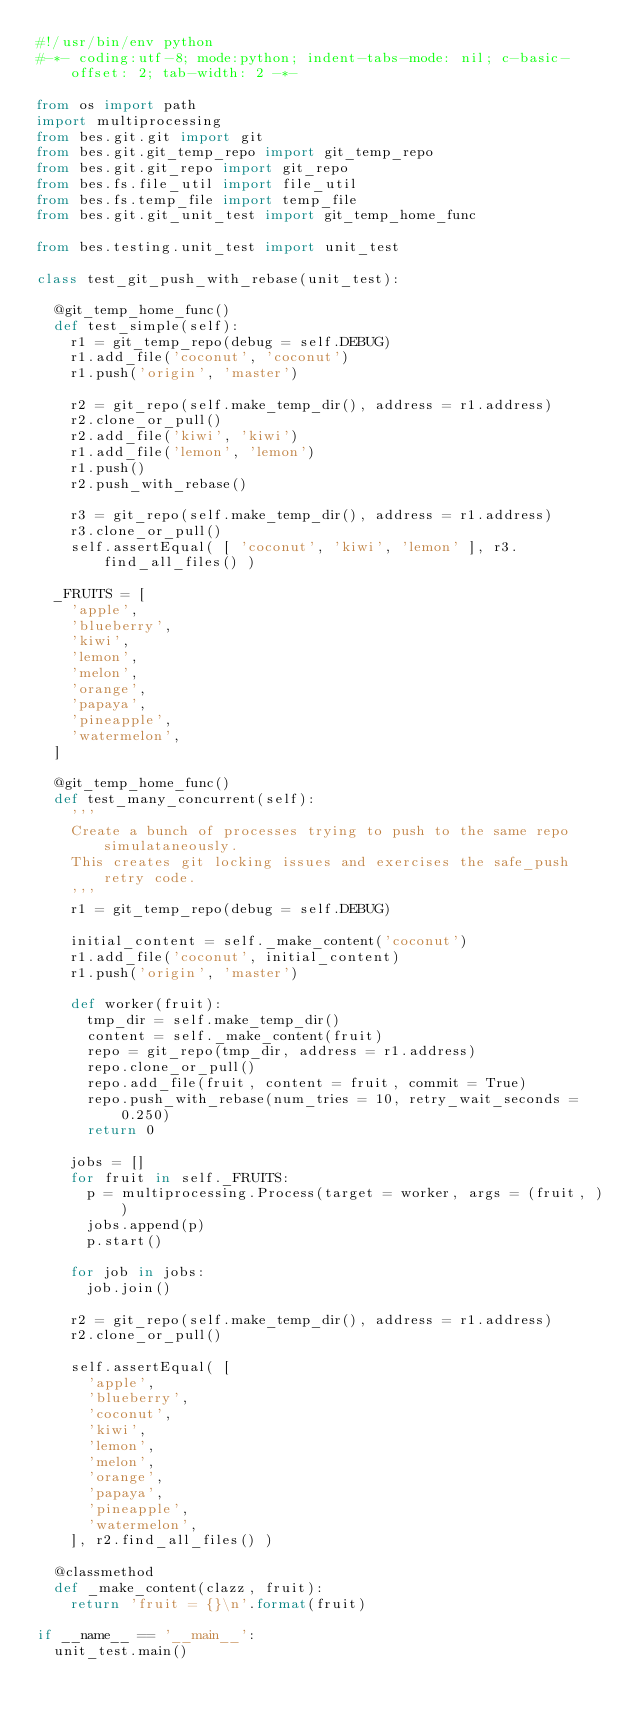Convert code to text. <code><loc_0><loc_0><loc_500><loc_500><_Python_>#!/usr/bin/env python
#-*- coding:utf-8; mode:python; indent-tabs-mode: nil; c-basic-offset: 2; tab-width: 2 -*-

from os import path
import multiprocessing
from bes.git.git import git
from bes.git.git_temp_repo import git_temp_repo
from bes.git.git_repo import git_repo
from bes.fs.file_util import file_util
from bes.fs.temp_file import temp_file
from bes.git.git_unit_test import git_temp_home_func

from bes.testing.unit_test import unit_test

class test_git_push_with_rebase(unit_test):

  @git_temp_home_func()
  def test_simple(self):
    r1 = git_temp_repo(debug = self.DEBUG)
    r1.add_file('coconut', 'coconut')
    r1.push('origin', 'master')

    r2 = git_repo(self.make_temp_dir(), address = r1.address)
    r2.clone_or_pull()
    r2.add_file('kiwi', 'kiwi')
    r1.add_file('lemon', 'lemon')
    r1.push()
    r2.push_with_rebase()
    
    r3 = git_repo(self.make_temp_dir(), address = r1.address)
    r3.clone_or_pull()
    self.assertEqual( [ 'coconut', 'kiwi', 'lemon' ], r3.find_all_files() )
    
  _FRUITS = [
    'apple',
    'blueberry',
    'kiwi',
    'lemon',
    'melon',
    'orange',
    'papaya',
    'pineapple',
    'watermelon',
  ]

  @git_temp_home_func()
  def test_many_concurrent(self):
    '''
    Create a bunch of processes trying to push to the same repo simulataneously.
    This creates git locking issues and exercises the safe_push retry code.
    '''
    r1 = git_temp_repo(debug = self.DEBUG)

    initial_content = self._make_content('coconut')
    r1.add_file('coconut', initial_content)
    r1.push('origin', 'master')
    
    def worker(fruit):
      tmp_dir = self.make_temp_dir()
      content = self._make_content(fruit)
      repo = git_repo(tmp_dir, address = r1.address)
      repo.clone_or_pull()
      repo.add_file(fruit, content = fruit, commit = True)
      repo.push_with_rebase(num_tries = 10, retry_wait_seconds = 0.250)
      return 0

    jobs = []
    for fruit in self._FRUITS:
      p = multiprocessing.Process(target = worker, args = (fruit, ))
      jobs.append(p)
      p.start()

    for job in jobs:
      job.join()

    r2 = git_repo(self.make_temp_dir(), address = r1.address)
    r2.clone_or_pull()

    self.assertEqual( [
      'apple',
      'blueberry',
      'coconut',
      'kiwi',
      'lemon',
      'melon',
      'orange',
      'papaya',
      'pineapple',
      'watermelon',
    ], r2.find_all_files() )

  @classmethod
  def _make_content(clazz, fruit):
    return 'fruit = {}\n'.format(fruit)
    
if __name__ == '__main__':
  unit_test.main()
</code> 